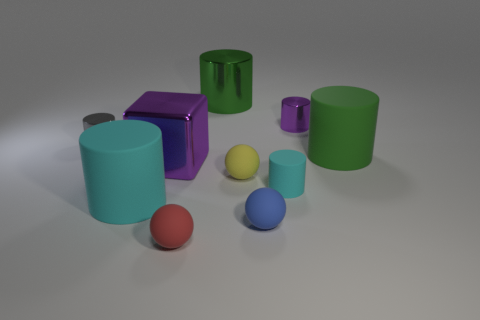Subtract all gray cylinders. How many cylinders are left? 5 Subtract all big green matte cylinders. How many cylinders are left? 5 Subtract all brown balls. Subtract all yellow blocks. How many balls are left? 3 Subtract all cylinders. How many objects are left? 4 Subtract all purple things. Subtract all blocks. How many objects are left? 7 Add 9 red rubber balls. How many red rubber balls are left? 10 Add 9 big cyan cylinders. How many big cyan cylinders exist? 10 Subtract 1 green cylinders. How many objects are left? 9 